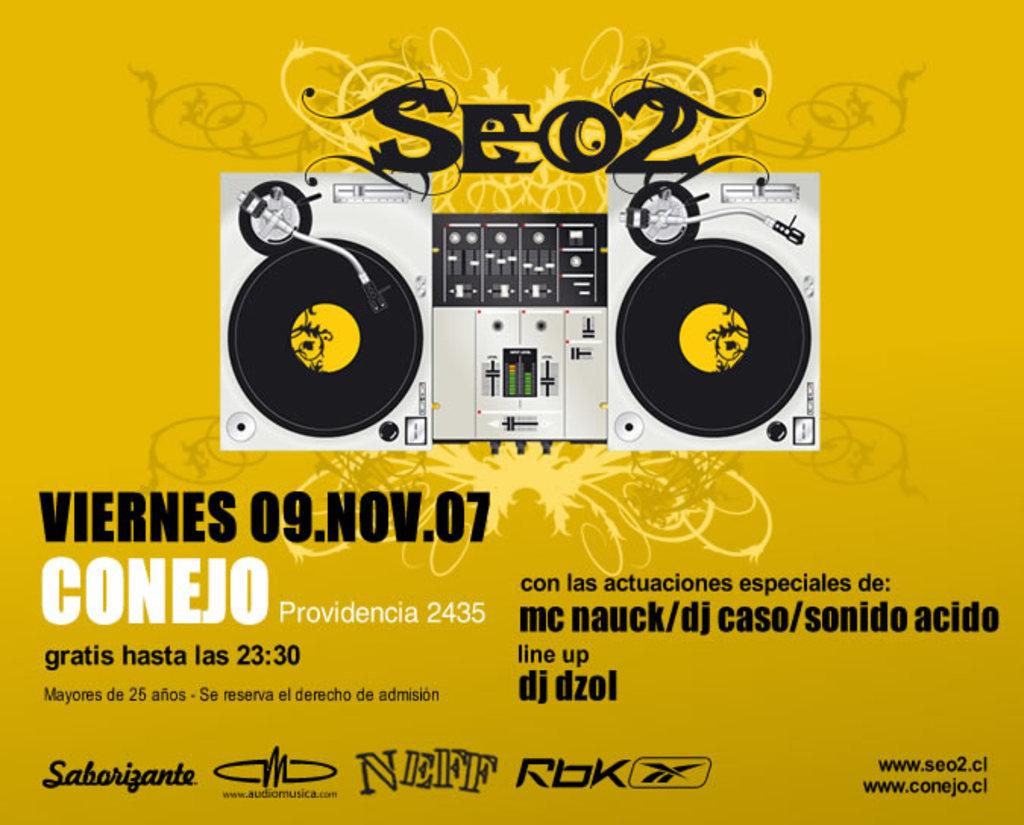What date is displayed?
Give a very brief answer. 09.nov.07. This is electronic board?
Make the answer very short. No. 